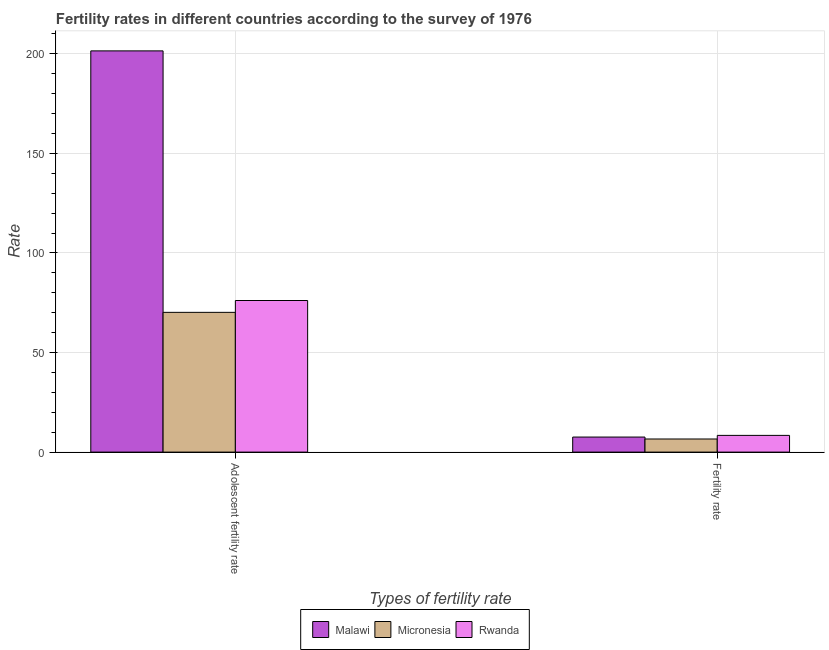How many groups of bars are there?
Ensure brevity in your answer.  2. Are the number of bars per tick equal to the number of legend labels?
Give a very brief answer. Yes. How many bars are there on the 1st tick from the left?
Offer a terse response. 3. How many bars are there on the 1st tick from the right?
Keep it short and to the point. 3. What is the label of the 2nd group of bars from the left?
Offer a very short reply. Fertility rate. What is the fertility rate in Micronesia?
Provide a short and direct response. 6.59. Across all countries, what is the maximum fertility rate?
Make the answer very short. 8.4. Across all countries, what is the minimum fertility rate?
Your response must be concise. 6.59. In which country was the fertility rate maximum?
Keep it short and to the point. Rwanda. In which country was the fertility rate minimum?
Your answer should be very brief. Micronesia. What is the total adolescent fertility rate in the graph?
Provide a succinct answer. 347.79. What is the difference between the fertility rate in Malawi and that in Rwanda?
Make the answer very short. -0.84. What is the difference between the fertility rate in Micronesia and the adolescent fertility rate in Rwanda?
Keep it short and to the point. -69.54. What is the average adolescent fertility rate per country?
Give a very brief answer. 115.93. What is the difference between the fertility rate and adolescent fertility rate in Malawi?
Your response must be concise. -193.93. In how many countries, is the fertility rate greater than 50 ?
Provide a succinct answer. 0. What is the ratio of the adolescent fertility rate in Malawi to that in Rwanda?
Ensure brevity in your answer.  2.65. Is the adolescent fertility rate in Rwanda less than that in Malawi?
Make the answer very short. Yes. What does the 1st bar from the left in Fertility rate represents?
Offer a very short reply. Malawi. What does the 1st bar from the right in Fertility rate represents?
Your answer should be compact. Rwanda. Are all the bars in the graph horizontal?
Provide a succinct answer. No. How many countries are there in the graph?
Make the answer very short. 3. Does the graph contain any zero values?
Your answer should be compact. No. What is the title of the graph?
Provide a short and direct response. Fertility rates in different countries according to the survey of 1976. What is the label or title of the X-axis?
Provide a succinct answer. Types of fertility rate. What is the label or title of the Y-axis?
Your answer should be compact. Rate. What is the Rate in Malawi in Adolescent fertility rate?
Your answer should be very brief. 201.48. What is the Rate in Micronesia in Adolescent fertility rate?
Make the answer very short. 70.18. What is the Rate in Rwanda in Adolescent fertility rate?
Keep it short and to the point. 76.13. What is the Rate in Malawi in Fertility rate?
Your answer should be very brief. 7.55. What is the Rate in Micronesia in Fertility rate?
Provide a succinct answer. 6.59. What is the Rate in Rwanda in Fertility rate?
Make the answer very short. 8.4. Across all Types of fertility rate, what is the maximum Rate of Malawi?
Offer a terse response. 201.48. Across all Types of fertility rate, what is the maximum Rate in Micronesia?
Ensure brevity in your answer.  70.18. Across all Types of fertility rate, what is the maximum Rate in Rwanda?
Give a very brief answer. 76.13. Across all Types of fertility rate, what is the minimum Rate of Malawi?
Your response must be concise. 7.55. Across all Types of fertility rate, what is the minimum Rate in Micronesia?
Offer a very short reply. 6.59. Across all Types of fertility rate, what is the minimum Rate in Rwanda?
Your answer should be very brief. 8.4. What is the total Rate of Malawi in the graph?
Your response must be concise. 209.04. What is the total Rate of Micronesia in the graph?
Provide a succinct answer. 76.77. What is the total Rate of Rwanda in the graph?
Your answer should be very brief. 84.52. What is the difference between the Rate in Malawi in Adolescent fertility rate and that in Fertility rate?
Your answer should be compact. 193.93. What is the difference between the Rate of Micronesia in Adolescent fertility rate and that in Fertility rate?
Provide a succinct answer. 63.59. What is the difference between the Rate of Rwanda in Adolescent fertility rate and that in Fertility rate?
Give a very brief answer. 67.73. What is the difference between the Rate of Malawi in Adolescent fertility rate and the Rate of Micronesia in Fertility rate?
Provide a short and direct response. 194.9. What is the difference between the Rate in Malawi in Adolescent fertility rate and the Rate in Rwanda in Fertility rate?
Provide a short and direct response. 193.08. What is the difference between the Rate in Micronesia in Adolescent fertility rate and the Rate in Rwanda in Fertility rate?
Your answer should be very brief. 61.78. What is the average Rate in Malawi per Types of fertility rate?
Make the answer very short. 104.52. What is the average Rate of Micronesia per Types of fertility rate?
Provide a short and direct response. 38.38. What is the average Rate in Rwanda per Types of fertility rate?
Provide a succinct answer. 42.26. What is the difference between the Rate of Malawi and Rate of Micronesia in Adolescent fertility rate?
Give a very brief answer. 131.3. What is the difference between the Rate in Malawi and Rate in Rwanda in Adolescent fertility rate?
Make the answer very short. 125.36. What is the difference between the Rate of Micronesia and Rate of Rwanda in Adolescent fertility rate?
Your answer should be very brief. -5.95. What is the difference between the Rate in Malawi and Rate in Rwanda in Fertility rate?
Provide a short and direct response. -0.84. What is the difference between the Rate in Micronesia and Rate in Rwanda in Fertility rate?
Make the answer very short. -1.81. What is the ratio of the Rate in Malawi in Adolescent fertility rate to that in Fertility rate?
Your answer should be compact. 26.67. What is the ratio of the Rate of Micronesia in Adolescent fertility rate to that in Fertility rate?
Your answer should be compact. 10.66. What is the ratio of the Rate of Rwanda in Adolescent fertility rate to that in Fertility rate?
Offer a terse response. 9.06. What is the difference between the highest and the second highest Rate of Malawi?
Make the answer very short. 193.93. What is the difference between the highest and the second highest Rate of Micronesia?
Ensure brevity in your answer.  63.59. What is the difference between the highest and the second highest Rate in Rwanda?
Offer a very short reply. 67.73. What is the difference between the highest and the lowest Rate of Malawi?
Offer a terse response. 193.93. What is the difference between the highest and the lowest Rate of Micronesia?
Make the answer very short. 63.59. What is the difference between the highest and the lowest Rate of Rwanda?
Ensure brevity in your answer.  67.73. 